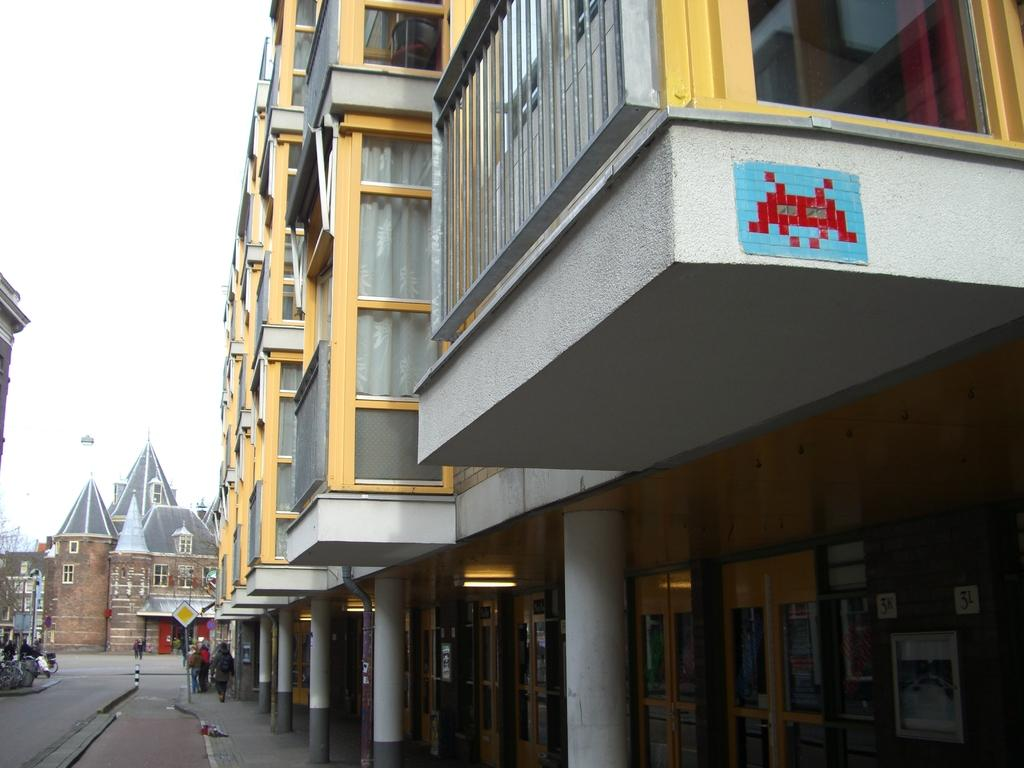What type of structures are present in the image? There are multiple buildings in the image. Can you describe any specific features of the buildings? The buildings have front edges visible and supporting pillars. What is happening on the left side of the image? There are people walking on the street on the left side of the image. What type of iron is being used by the son in the image? There is no son or iron present in the image. 